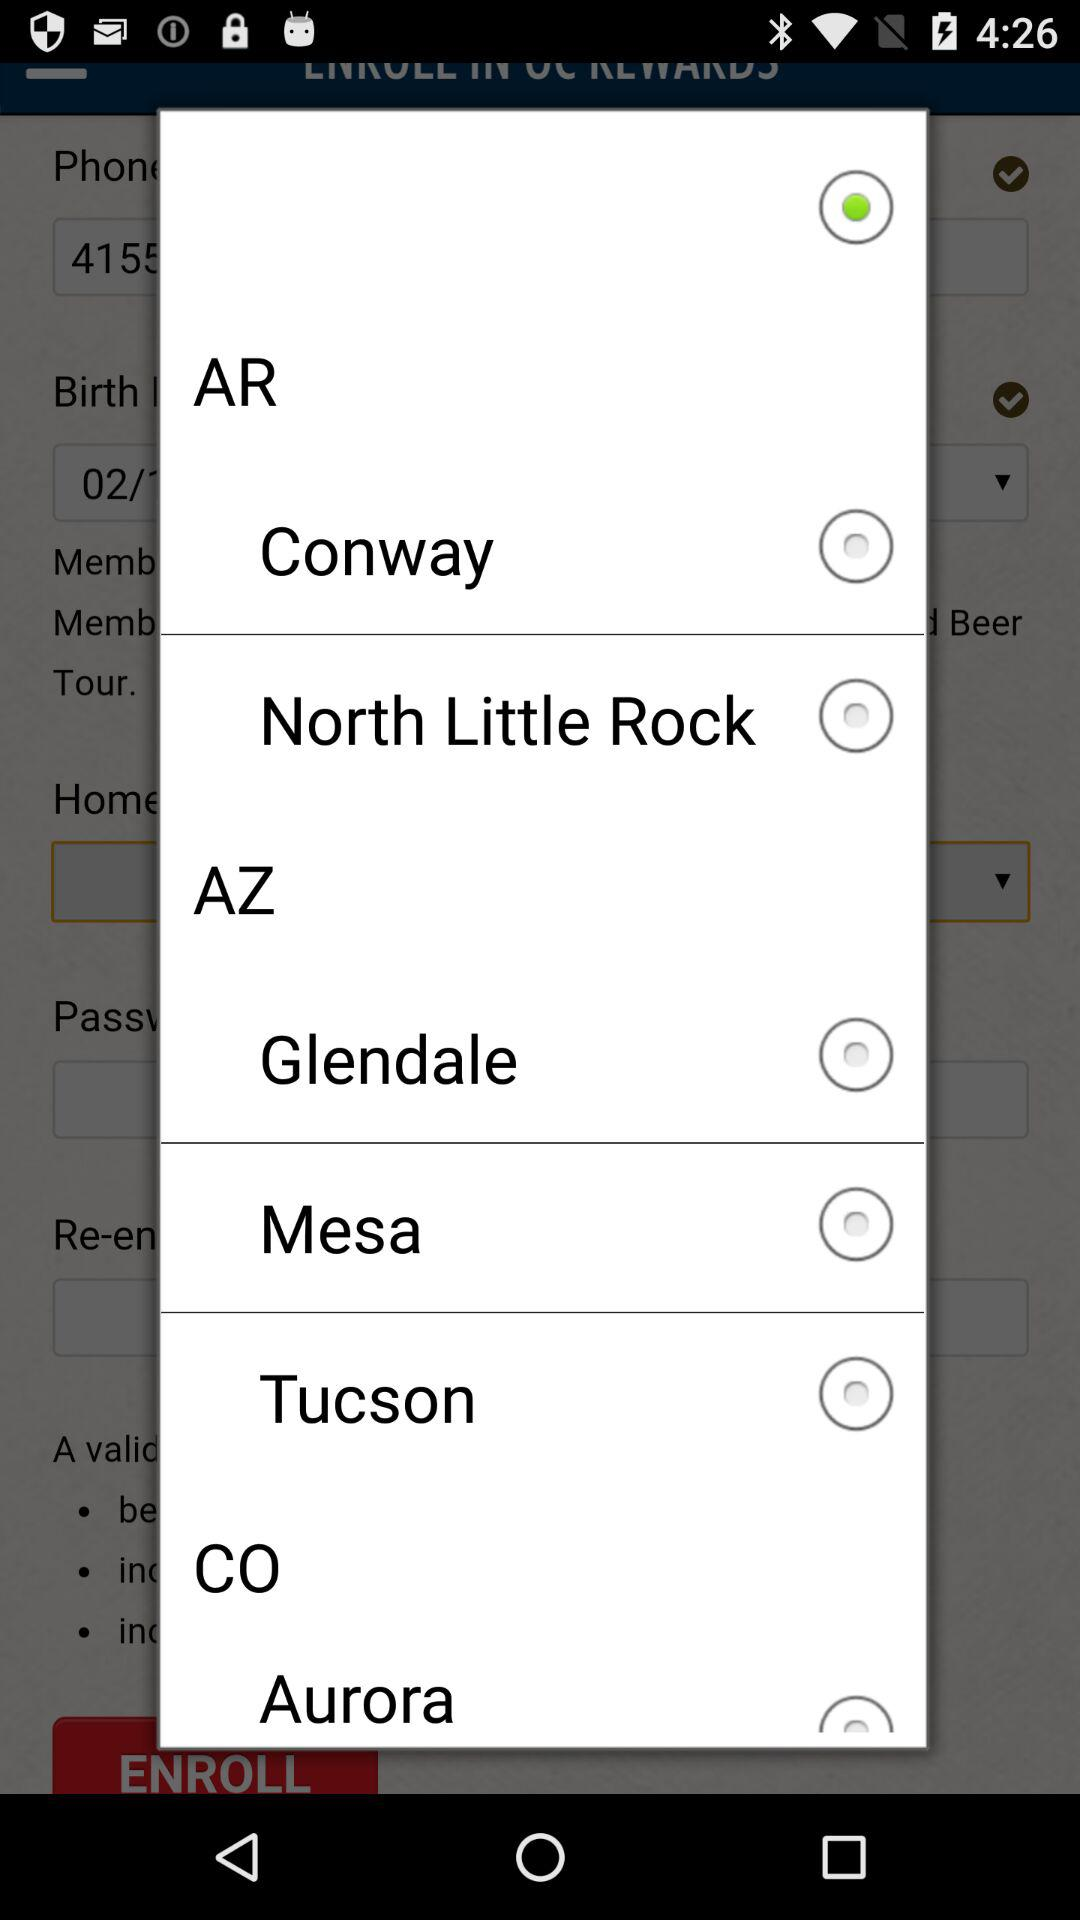Which option is selected?
When the provided information is insufficient, respond with <no answer>. <no answer> 